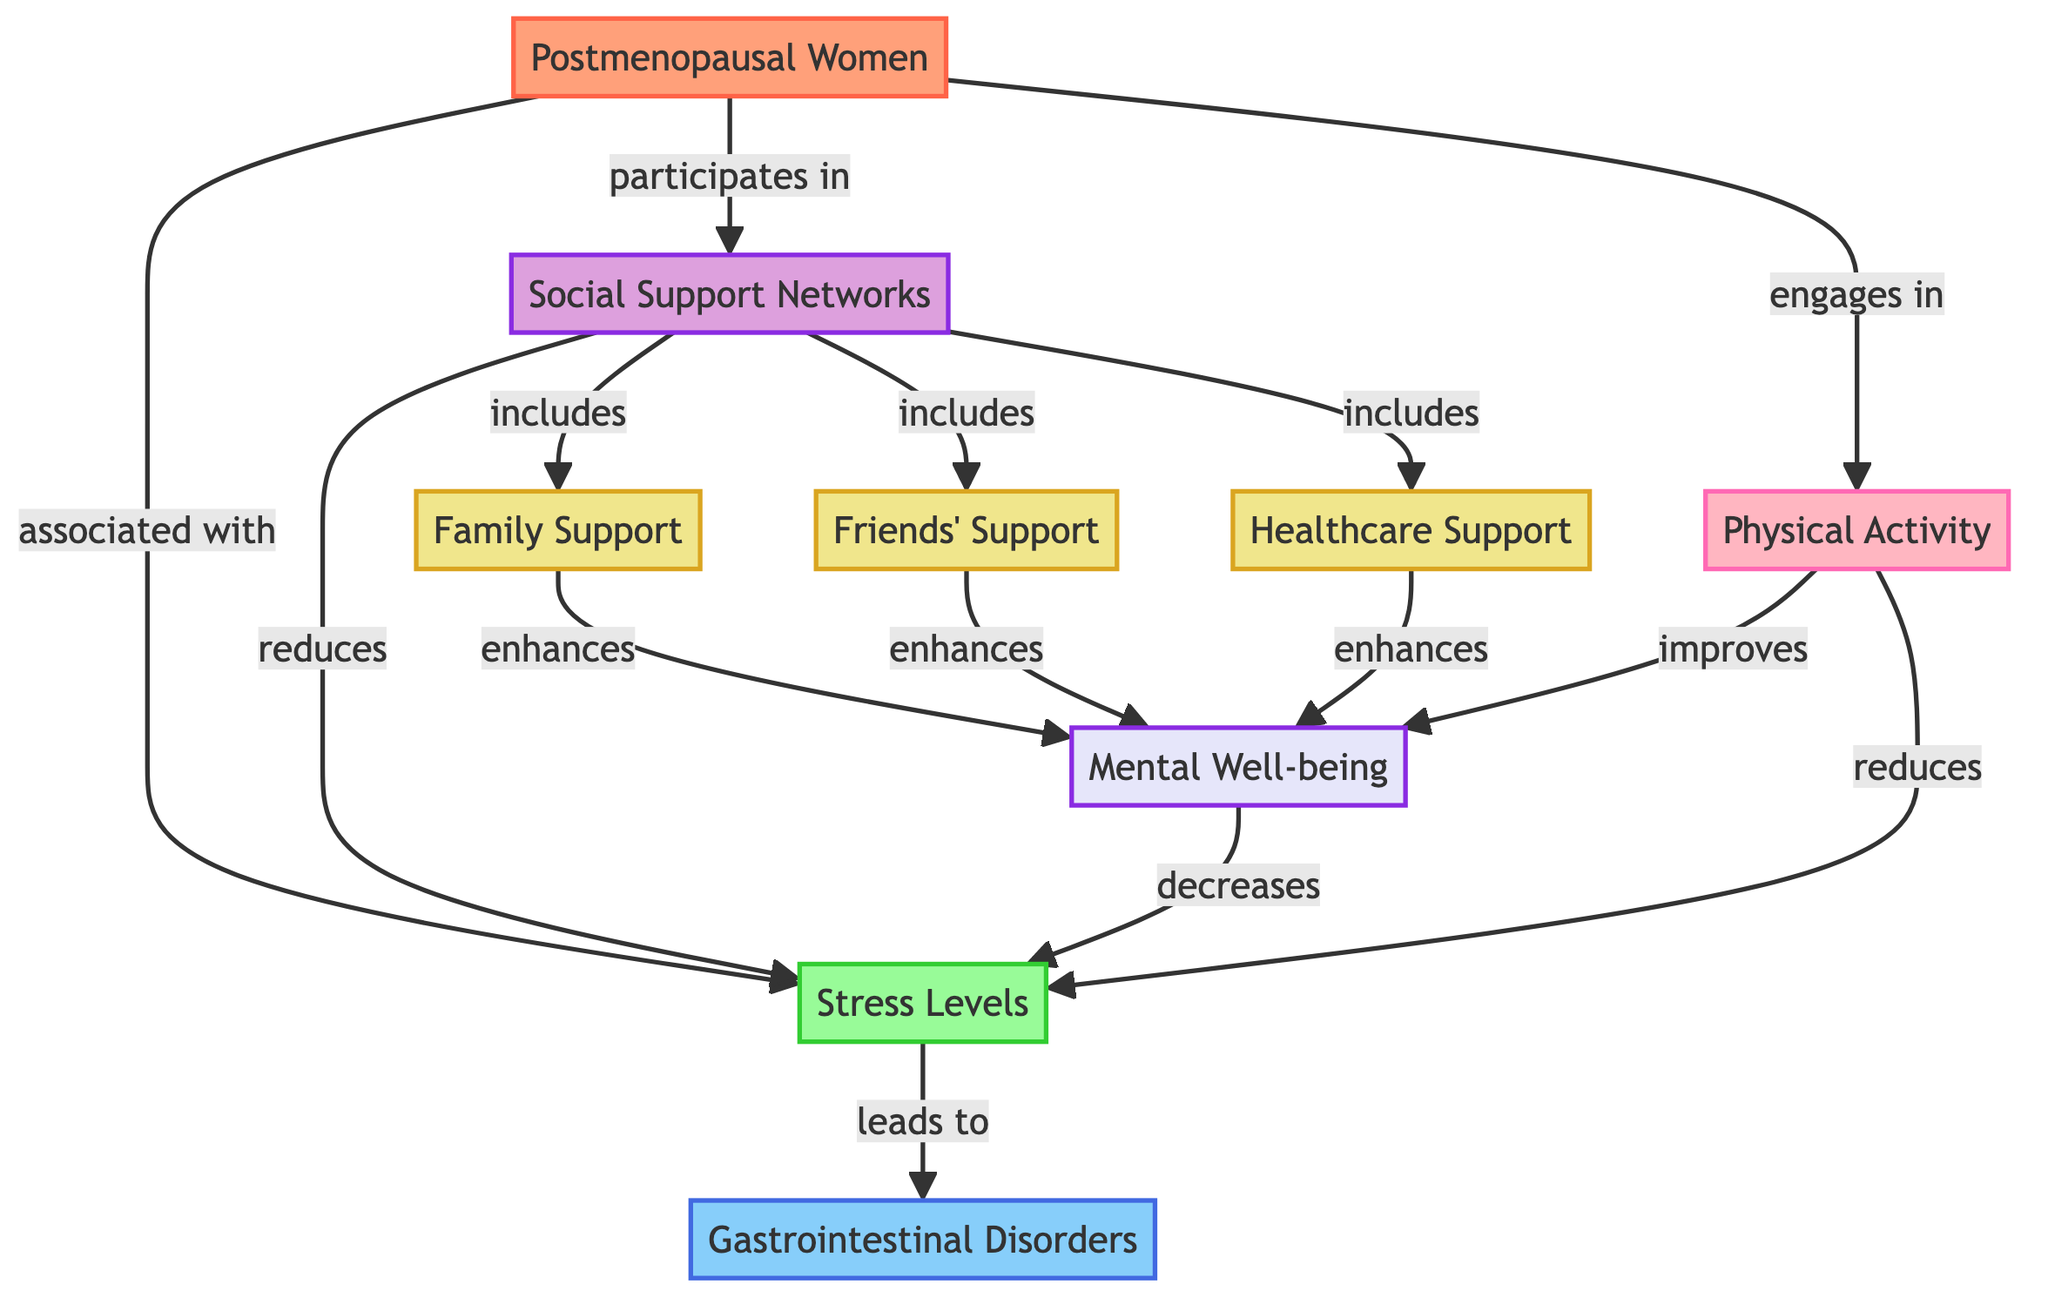What is the main group of individuals represented in the diagram? The main group of individuals is "Postmenopausal Women," as indicated by the labeled node at the beginning of the diagram.
Answer: Postmenopausal Women How many types of social support are identified in the diagram? The diagram lists three types of social support: Family Support, Friends' Support, and Healthcare Support, which can be counted directly from the support nodes.
Answer: 3 What is the relationship between Social Support Networks and Stress Levels? The relationship is that Social Support Networks reduce Stress Levels, as indicated by the directed edge showing this connection in the diagram.
Answer: reduces Which factor leads to Gastrointestinal Disorders? The factor that leads to Gastrointestinal Disorders is "Stress Levels," shown by the relationship directed from Stress Levels to Gastrointestinal Disorders in the diagram.
Answer: Stress Levels Which factors enhance Mental Well-being according to the social support component? The factors that enhance Mental Well-being are Family Support, Friends' Support, and Healthcare Support, all directly linked to Mental Well-being in the diagram.
Answer: Family Support, Friends' Support, Healthcare Support How does Physical Activity influence Mental Well-being? Physical Activity improves Mental Well-being as indicated by the directed connection from Physical Activity to Mental Well-being in the diagram.
Answer: improves What is the overall effect of Physical Activity on Stress Levels in postmenopausal women? The overall effect of Physical Activity is that it reduces Stress Levels, as shown by the directed edge going from Physical Activity to Stress Levels.
Answer: reduces What are the three support nodes included in Social Support Networks? The three support nodes included are Family Support, Friends' Support, and Healthcare Support, as specified in the diagram.
Answer: Family Support, Friends' Support, Healthcare Support What condition has a direct association with Postmenopausal Women? The condition directly associated with Postmenopausal Women is Stress Levels, as indicated by the connection in the diagram.
Answer: Stress Levels 